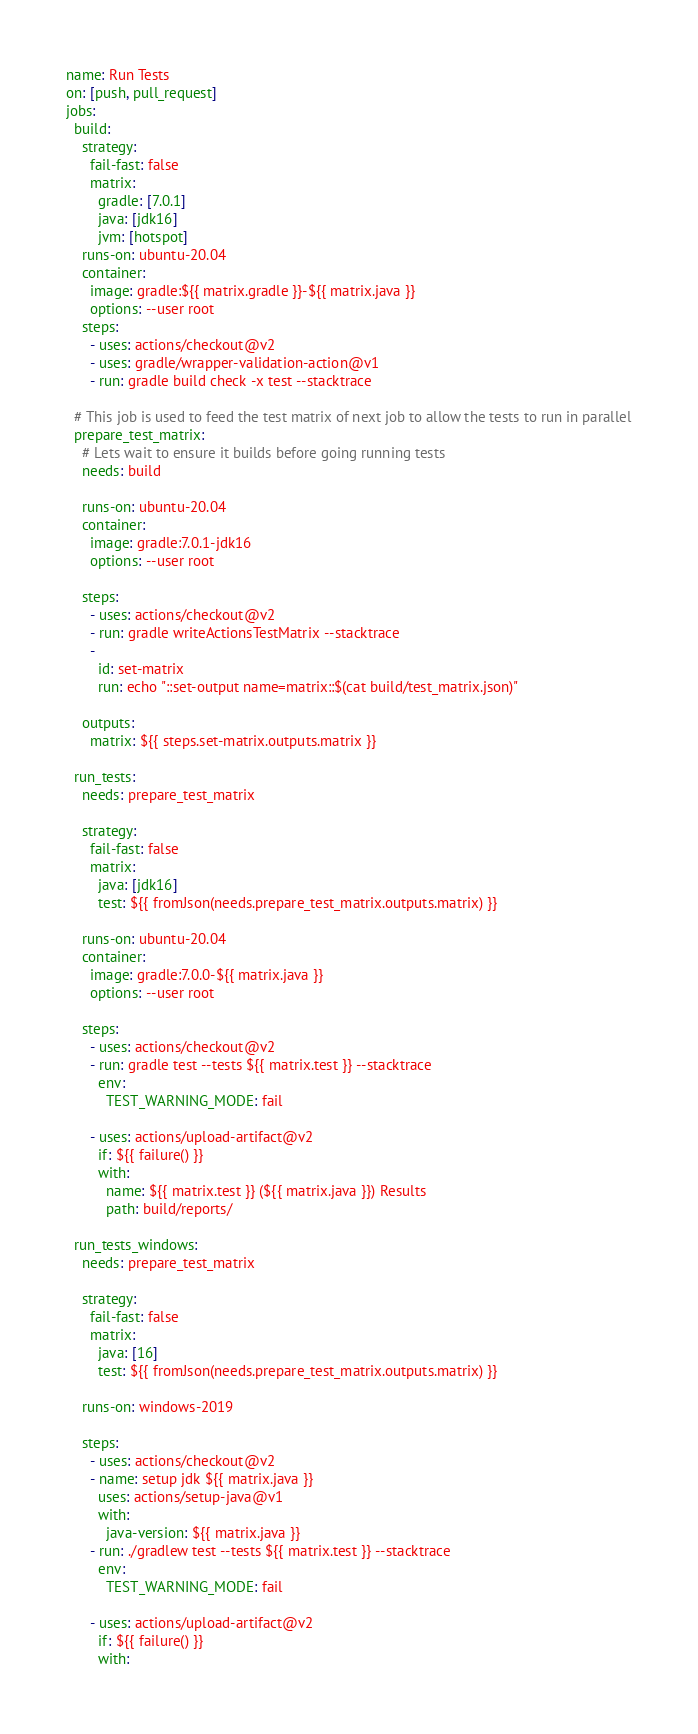Convert code to text. <code><loc_0><loc_0><loc_500><loc_500><_YAML_>name: Run Tests
on: [push, pull_request]
jobs:
  build:
    strategy:
      fail-fast: false
      matrix:
        gradle: [7.0.1]
        java: [jdk16]
        jvm: [hotspot]
    runs-on: ubuntu-20.04
    container:
      image: gradle:${{ matrix.gradle }}-${{ matrix.java }}
      options: --user root
    steps:
      - uses: actions/checkout@v2
      - uses: gradle/wrapper-validation-action@v1
      - run: gradle build check -x test --stacktrace

  # This job is used to feed the test matrix of next job to allow the tests to run in parallel
  prepare_test_matrix:
    # Lets wait to ensure it builds before going running tests
    needs: build

    runs-on: ubuntu-20.04
    container:
      image: gradle:7.0.1-jdk16
      options: --user root

    steps:
      - uses: actions/checkout@v2
      - run: gradle writeActionsTestMatrix --stacktrace
      -
        id: set-matrix
        run: echo "::set-output name=matrix::$(cat build/test_matrix.json)"

    outputs:
      matrix: ${{ steps.set-matrix.outputs.matrix }}

  run_tests:
    needs: prepare_test_matrix

    strategy:
      fail-fast: false
      matrix:
        java: [jdk16]
        test: ${{ fromJson(needs.prepare_test_matrix.outputs.matrix) }}

    runs-on: ubuntu-20.04
    container:
      image: gradle:7.0.0-${{ matrix.java }}
      options: --user root

    steps:
      - uses: actions/checkout@v2
      - run: gradle test --tests ${{ matrix.test }} --stacktrace
        env:
          TEST_WARNING_MODE: fail

      - uses: actions/upload-artifact@v2
        if: ${{ failure() }}
        with:
          name: ${{ matrix.test }} (${{ matrix.java }}) Results
          path: build/reports/

  run_tests_windows:
    needs: prepare_test_matrix

    strategy:
      fail-fast: false
      matrix:
        java: [16]
        test: ${{ fromJson(needs.prepare_test_matrix.outputs.matrix) }}

    runs-on: windows-2019

    steps:
      - uses: actions/checkout@v2
      - name: setup jdk ${{ matrix.java }}
        uses: actions/setup-java@v1
        with:
          java-version: ${{ matrix.java }}
      - run: ./gradlew test --tests ${{ matrix.test }} --stacktrace
        env:
          TEST_WARNING_MODE: fail

      - uses: actions/upload-artifact@v2
        if: ${{ failure() }}
        with:</code> 